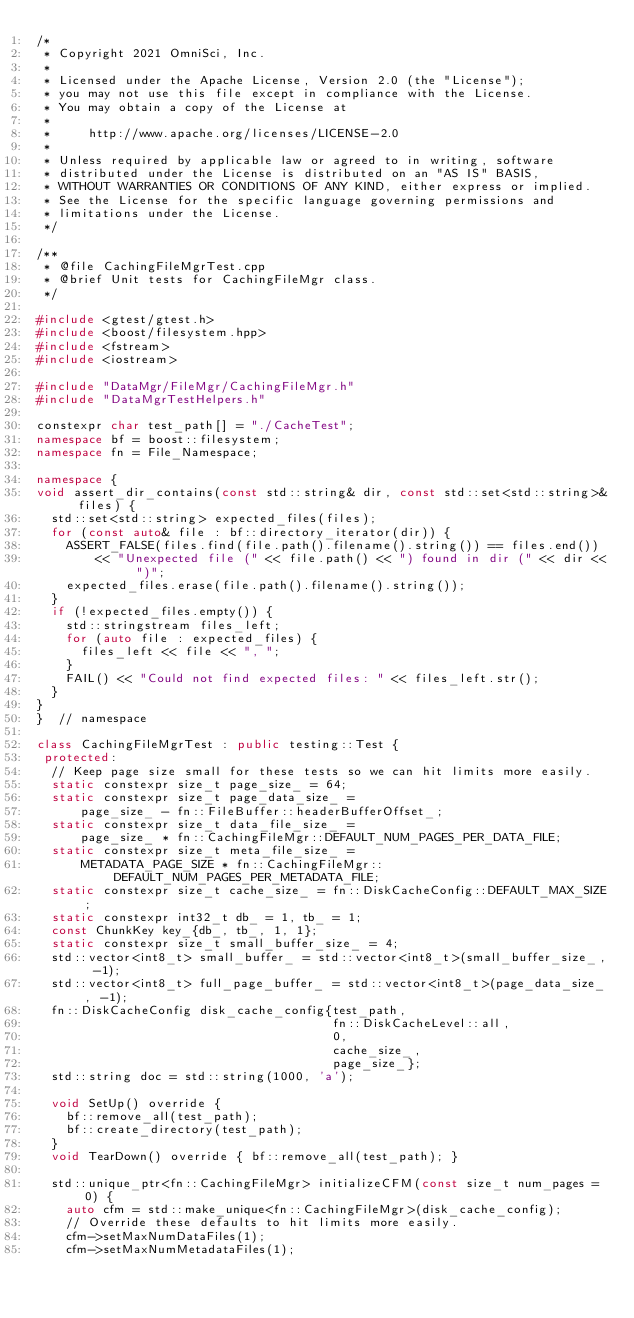Convert code to text. <code><loc_0><loc_0><loc_500><loc_500><_C++_>/*
 * Copyright 2021 OmniSci, Inc.
 *
 * Licensed under the Apache License, Version 2.0 (the "License");
 * you may not use this file except in compliance with the License.
 * You may obtain a copy of the License at
 *
 *     http://www.apache.org/licenses/LICENSE-2.0
 *
 * Unless required by applicable law or agreed to in writing, software
 * distributed under the License is distributed on an "AS IS" BASIS,
 * WITHOUT WARRANTIES OR CONDITIONS OF ANY KIND, either express or implied.
 * See the License for the specific language governing permissions and
 * limitations under the License.
 */

/**
 * @file CachingFileMgrTest.cpp
 * @brief Unit tests for CachingFileMgr class.
 */

#include <gtest/gtest.h>
#include <boost/filesystem.hpp>
#include <fstream>
#include <iostream>

#include "DataMgr/FileMgr/CachingFileMgr.h"
#include "DataMgrTestHelpers.h"

constexpr char test_path[] = "./CacheTest";
namespace bf = boost::filesystem;
namespace fn = File_Namespace;

namespace {
void assert_dir_contains(const std::string& dir, const std::set<std::string>& files) {
  std::set<std::string> expected_files(files);
  for (const auto& file : bf::directory_iterator(dir)) {
    ASSERT_FALSE(files.find(file.path().filename().string()) == files.end())
        << "Unexpected file (" << file.path() << ") found in dir (" << dir << ")";
    expected_files.erase(file.path().filename().string());
  }
  if (!expected_files.empty()) {
    std::stringstream files_left;
    for (auto file : expected_files) {
      files_left << file << ", ";
    }
    FAIL() << "Could not find expected files: " << files_left.str();
  }
}
}  // namespace

class CachingFileMgrTest : public testing::Test {
 protected:
  // Keep page size small for these tests so we can hit limits more easily.
  static constexpr size_t page_size_ = 64;
  static constexpr size_t page_data_size_ =
      page_size_ - fn::FileBuffer::headerBufferOffset_;
  static constexpr size_t data_file_size_ =
      page_size_ * fn::CachingFileMgr::DEFAULT_NUM_PAGES_PER_DATA_FILE;
  static constexpr size_t meta_file_size_ =
      METADATA_PAGE_SIZE * fn::CachingFileMgr::DEFAULT_NUM_PAGES_PER_METADATA_FILE;
  static constexpr size_t cache_size_ = fn::DiskCacheConfig::DEFAULT_MAX_SIZE;
  static constexpr int32_t db_ = 1, tb_ = 1;
  const ChunkKey key_{db_, tb_, 1, 1};
  static constexpr size_t small_buffer_size_ = 4;
  std::vector<int8_t> small_buffer_ = std::vector<int8_t>(small_buffer_size_, -1);
  std::vector<int8_t> full_page_buffer_ = std::vector<int8_t>(page_data_size_, -1);
  fn::DiskCacheConfig disk_cache_config{test_path,
                                        fn::DiskCacheLevel::all,
                                        0,
                                        cache_size_,
                                        page_size_};
  std::string doc = std::string(1000, 'a');

  void SetUp() override {
    bf::remove_all(test_path);
    bf::create_directory(test_path);
  }
  void TearDown() override { bf::remove_all(test_path); }

  std::unique_ptr<fn::CachingFileMgr> initializeCFM(const size_t num_pages = 0) {
    auto cfm = std::make_unique<fn::CachingFileMgr>(disk_cache_config);
    // Override these defaults to hit limits more easily.
    cfm->setMaxNumDataFiles(1);
    cfm->setMaxNumMetadataFiles(1);</code> 